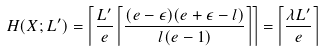Convert formula to latex. <formula><loc_0><loc_0><loc_500><loc_500>H ( X ; L ^ { \prime } ) = \left \lceil \frac { L ^ { \prime } } { e } \left \lceil \frac { ( e - \epsilon ) ( e + \epsilon - l ) } { l ( e - 1 ) } \right \rceil \right \rceil = \left \lceil \frac { \lambda L ^ { \prime } } { e } \right \rceil</formula> 